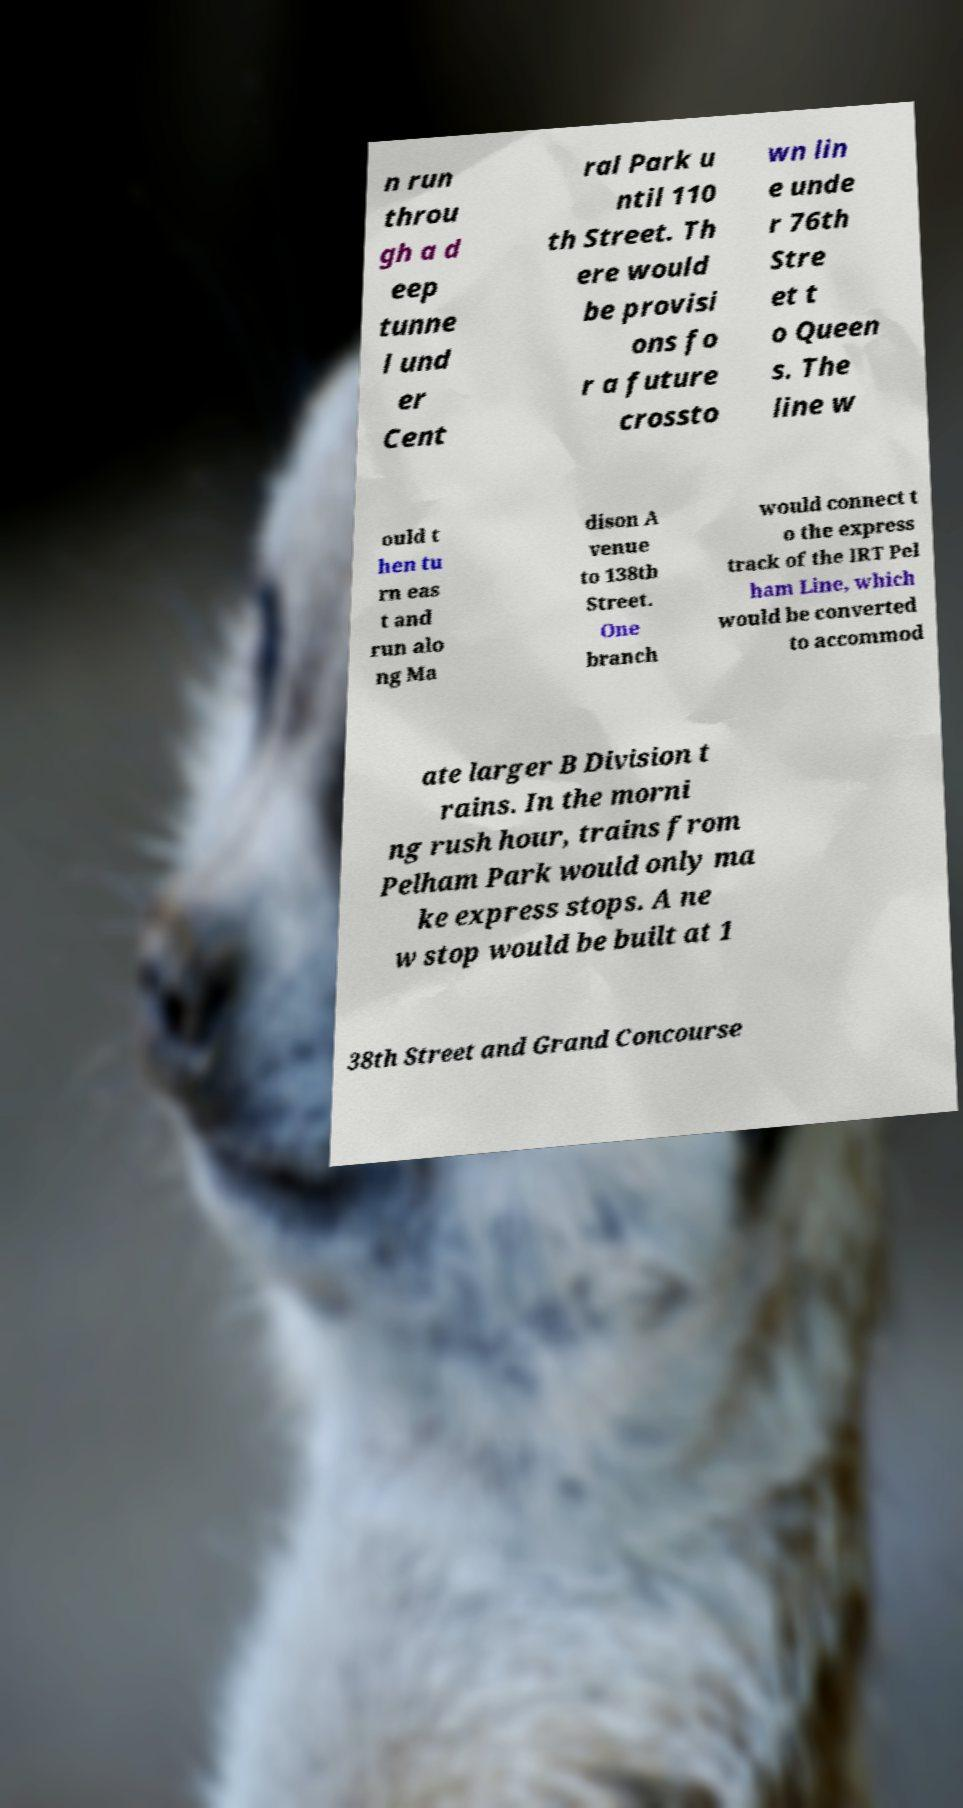Can you read and provide the text displayed in the image?This photo seems to have some interesting text. Can you extract and type it out for me? n run throu gh a d eep tunne l und er Cent ral Park u ntil 110 th Street. Th ere would be provisi ons fo r a future crossto wn lin e unde r 76th Stre et t o Queen s. The line w ould t hen tu rn eas t and run alo ng Ma dison A venue to 138th Street. One branch would connect t o the express track of the IRT Pel ham Line, which would be converted to accommod ate larger B Division t rains. In the morni ng rush hour, trains from Pelham Park would only ma ke express stops. A ne w stop would be built at 1 38th Street and Grand Concourse 